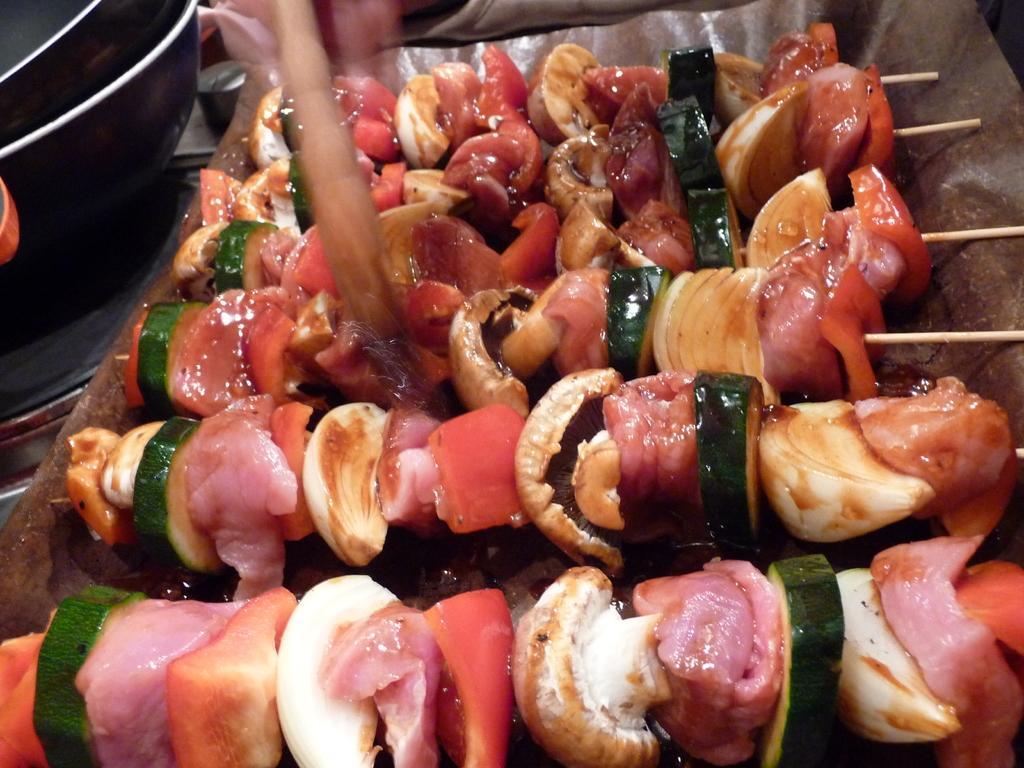In one or two sentences, can you explain what this image depicts? This image consists of food which is in the center. On the left side there are objects which are black in colour. 